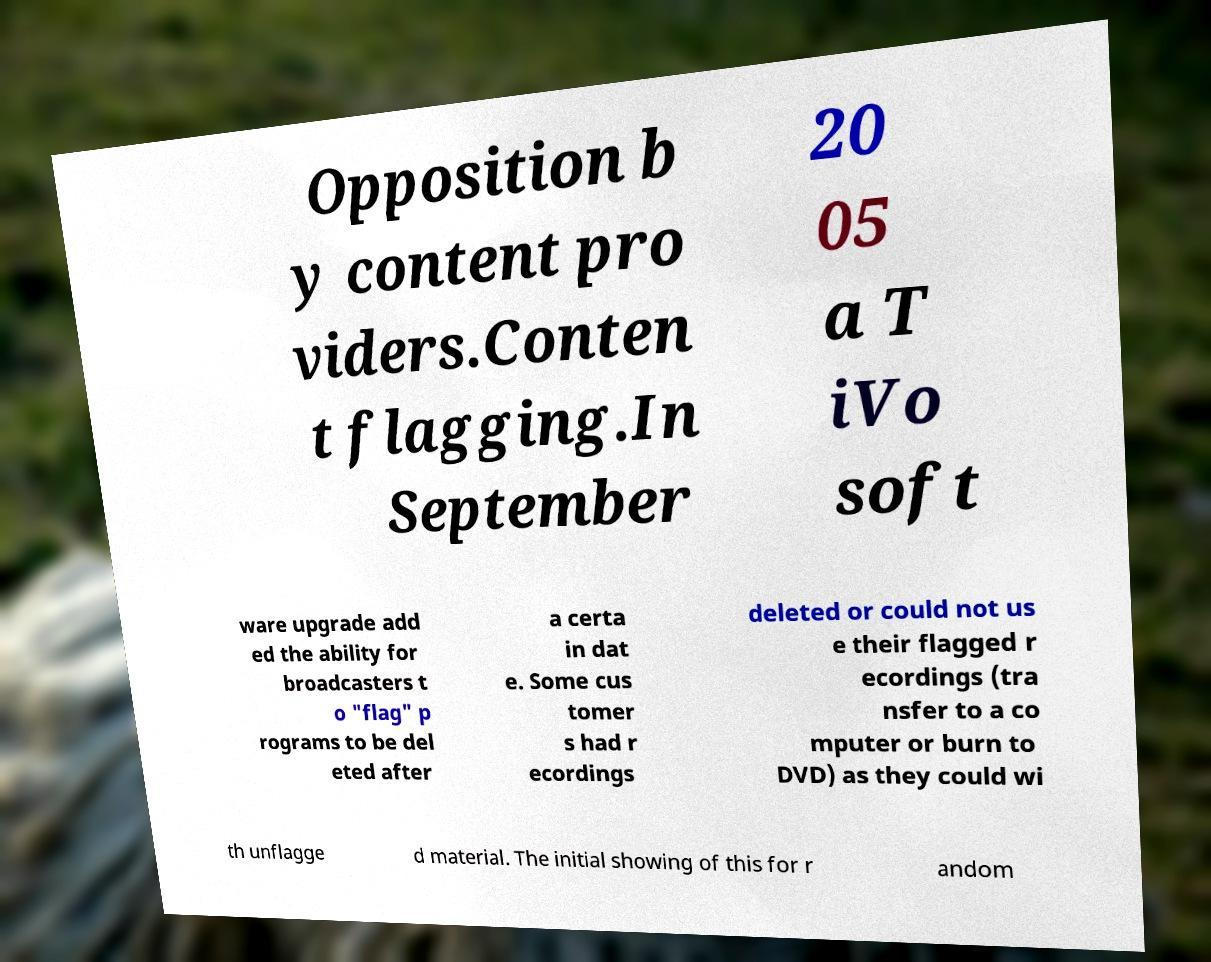Could you extract and type out the text from this image? Opposition b y content pro viders.Conten t flagging.In September 20 05 a T iVo soft ware upgrade add ed the ability for broadcasters t o "flag" p rograms to be del eted after a certa in dat e. Some cus tomer s had r ecordings deleted or could not us e their flagged r ecordings (tra nsfer to a co mputer or burn to DVD) as they could wi th unflagge d material. The initial showing of this for r andom 